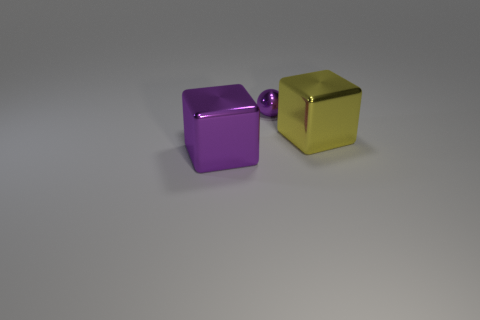Add 3 tiny green matte spheres. How many objects exist? 6 Subtract all cubes. How many objects are left? 1 Add 2 large things. How many large things exist? 4 Subtract 0 red blocks. How many objects are left? 3 Subtract all tiny balls. Subtract all tiny purple rubber cylinders. How many objects are left? 2 Add 2 purple balls. How many purple balls are left? 3 